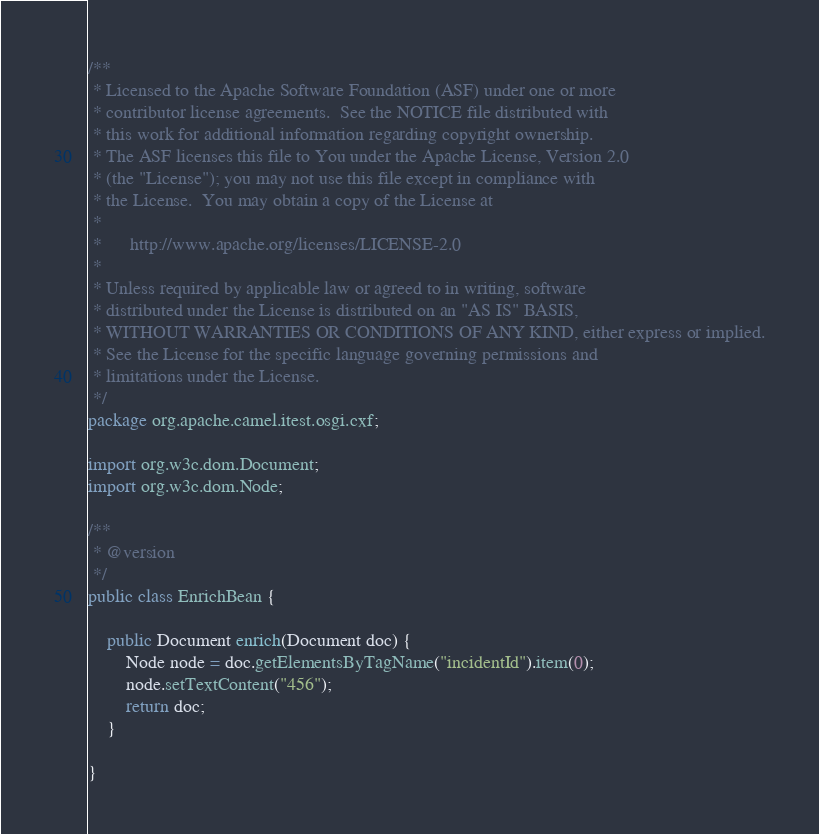Convert code to text. <code><loc_0><loc_0><loc_500><loc_500><_Java_>/**
 * Licensed to the Apache Software Foundation (ASF) under one or more
 * contributor license agreements.  See the NOTICE file distributed with
 * this work for additional information regarding copyright ownership.
 * The ASF licenses this file to You under the Apache License, Version 2.0
 * (the "License"); you may not use this file except in compliance with
 * the License.  You may obtain a copy of the License at
 *
 *      http://www.apache.org/licenses/LICENSE-2.0
 *
 * Unless required by applicable law or agreed to in writing, software
 * distributed under the License is distributed on an "AS IS" BASIS,
 * WITHOUT WARRANTIES OR CONDITIONS OF ANY KIND, either express or implied.
 * See the License for the specific language governing permissions and
 * limitations under the License.
 */
package org.apache.camel.itest.osgi.cxf;

import org.w3c.dom.Document;
import org.w3c.dom.Node;

/**
 * @version 
 */
public class EnrichBean {

    public Document enrich(Document doc) {
        Node node = doc.getElementsByTagName("incidentId").item(0);
        node.setTextContent("456");
        return doc;
    }

}
</code> 